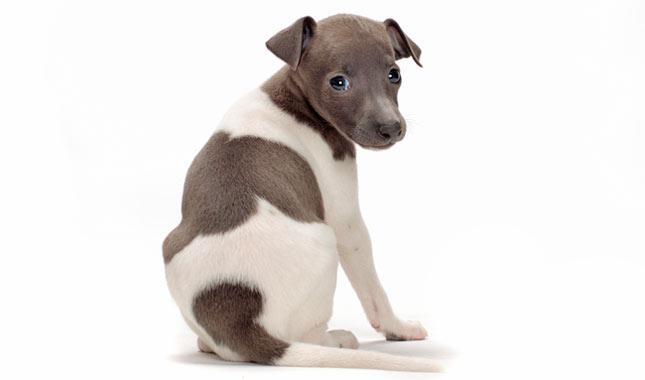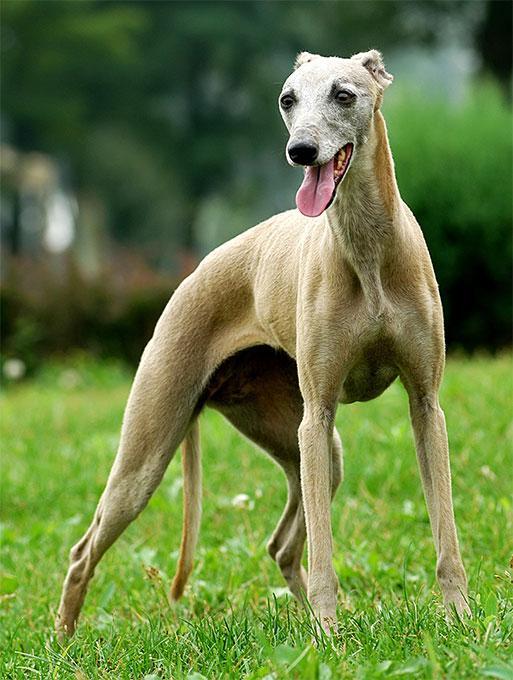The first image is the image on the left, the second image is the image on the right. For the images shown, is this caption "An image contains a row of at least four dogs." true? Answer yes or no. No. The first image is the image on the left, the second image is the image on the right. For the images shown, is this caption "There is 1 dog standing outside." true? Answer yes or no. Yes. 